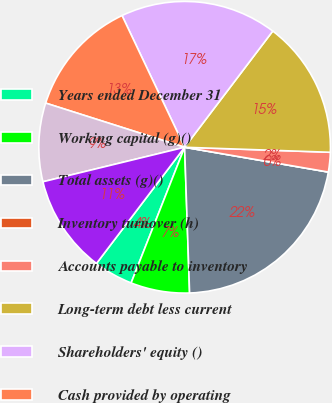Convert chart to OTSL. <chart><loc_0><loc_0><loc_500><loc_500><pie_chart><fcel>Years ended December 31<fcel>Working capital (g)()<fcel>Total assets (g)()<fcel>Inventory turnover (h)<fcel>Accounts payable to inventory<fcel>Long-term debt less current<fcel>Shareholders' equity ()<fcel>Cash provided by operating<fcel>Capital expenditures ()<fcel>Free cash flow (j)()<nl><fcel>4.35%<fcel>6.52%<fcel>21.74%<fcel>0.0%<fcel>2.17%<fcel>15.22%<fcel>17.39%<fcel>13.04%<fcel>8.7%<fcel>10.87%<nl></chart> 